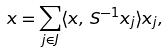Convert formula to latex. <formula><loc_0><loc_0><loc_500><loc_500>x = \sum _ { j \in J } \langle x , \, S ^ { - 1 } x _ { j } \rangle x _ { j } ,</formula> 